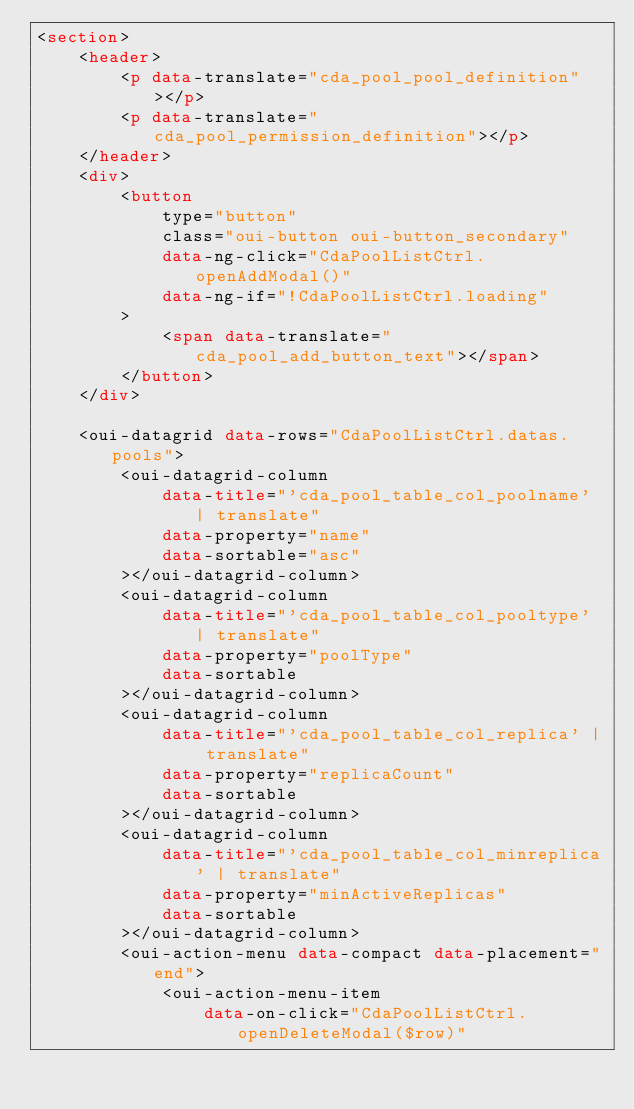<code> <loc_0><loc_0><loc_500><loc_500><_HTML_><section>
    <header>
        <p data-translate="cda_pool_pool_definition"></p>
        <p data-translate="cda_pool_permission_definition"></p>
    </header>
    <div>
        <button
            type="button"
            class="oui-button oui-button_secondary"
            data-ng-click="CdaPoolListCtrl.openAddModal()"
            data-ng-if="!CdaPoolListCtrl.loading"
        >
            <span data-translate="cda_pool_add_button_text"></span>
        </button>
    </div>

    <oui-datagrid data-rows="CdaPoolListCtrl.datas.pools">
        <oui-datagrid-column
            data-title="'cda_pool_table_col_poolname' | translate"
            data-property="name"
            data-sortable="asc"
        ></oui-datagrid-column>
        <oui-datagrid-column
            data-title="'cda_pool_table_col_pooltype' | translate"
            data-property="poolType"
            data-sortable
        ></oui-datagrid-column>
        <oui-datagrid-column
            data-title="'cda_pool_table_col_replica' | translate"
            data-property="replicaCount"
            data-sortable
        ></oui-datagrid-column>
        <oui-datagrid-column
            data-title="'cda_pool_table_col_minreplica' | translate"
            data-property="minActiveReplicas"
            data-sortable
        ></oui-datagrid-column>
        <oui-action-menu data-compact data-placement="end">
            <oui-action-menu-item
                data-on-click="CdaPoolListCtrl.openDeleteModal($row)"</code> 